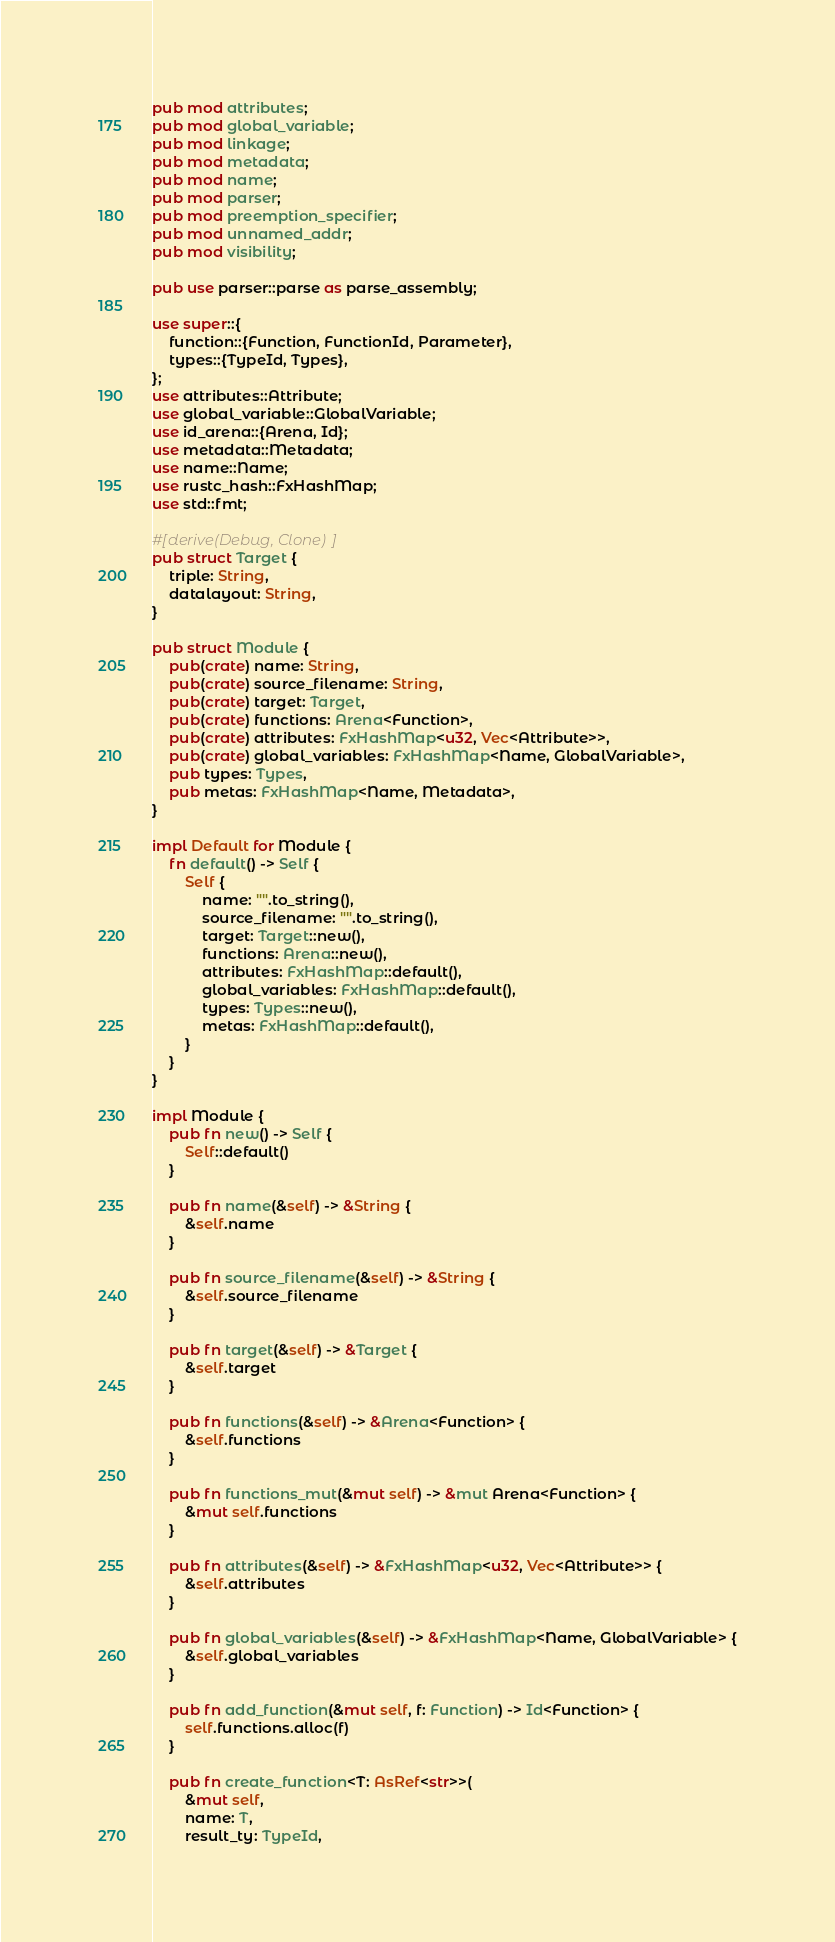<code> <loc_0><loc_0><loc_500><loc_500><_Rust_>pub mod attributes;
pub mod global_variable;
pub mod linkage;
pub mod metadata;
pub mod name;
pub mod parser;
pub mod preemption_specifier;
pub mod unnamed_addr;
pub mod visibility;

pub use parser::parse as parse_assembly;

use super::{
    function::{Function, FunctionId, Parameter},
    types::{TypeId, Types},
};
use attributes::Attribute;
use global_variable::GlobalVariable;
use id_arena::{Arena, Id};
use metadata::Metadata;
use name::Name;
use rustc_hash::FxHashMap;
use std::fmt;

#[derive(Debug, Clone)]
pub struct Target {
    triple: String,
    datalayout: String,
}

pub struct Module {
    pub(crate) name: String,
    pub(crate) source_filename: String,
    pub(crate) target: Target,
    pub(crate) functions: Arena<Function>,
    pub(crate) attributes: FxHashMap<u32, Vec<Attribute>>,
    pub(crate) global_variables: FxHashMap<Name, GlobalVariable>,
    pub types: Types,
    pub metas: FxHashMap<Name, Metadata>,
}

impl Default for Module {
    fn default() -> Self {
        Self {
            name: "".to_string(),
            source_filename: "".to_string(),
            target: Target::new(),
            functions: Arena::new(),
            attributes: FxHashMap::default(),
            global_variables: FxHashMap::default(),
            types: Types::new(),
            metas: FxHashMap::default(),
        }
    }
}

impl Module {
    pub fn new() -> Self {
        Self::default()
    }

    pub fn name(&self) -> &String {
        &self.name
    }

    pub fn source_filename(&self) -> &String {
        &self.source_filename
    }

    pub fn target(&self) -> &Target {
        &self.target
    }

    pub fn functions(&self) -> &Arena<Function> {
        &self.functions
    }

    pub fn functions_mut(&mut self) -> &mut Arena<Function> {
        &mut self.functions
    }

    pub fn attributes(&self) -> &FxHashMap<u32, Vec<Attribute>> {
        &self.attributes
    }

    pub fn global_variables(&self) -> &FxHashMap<Name, GlobalVariable> {
        &self.global_variables
    }

    pub fn add_function(&mut self, f: Function) -> Id<Function> {
        self.functions.alloc(f)
    }

    pub fn create_function<T: AsRef<str>>(
        &mut self,
        name: T,
        result_ty: TypeId,</code> 